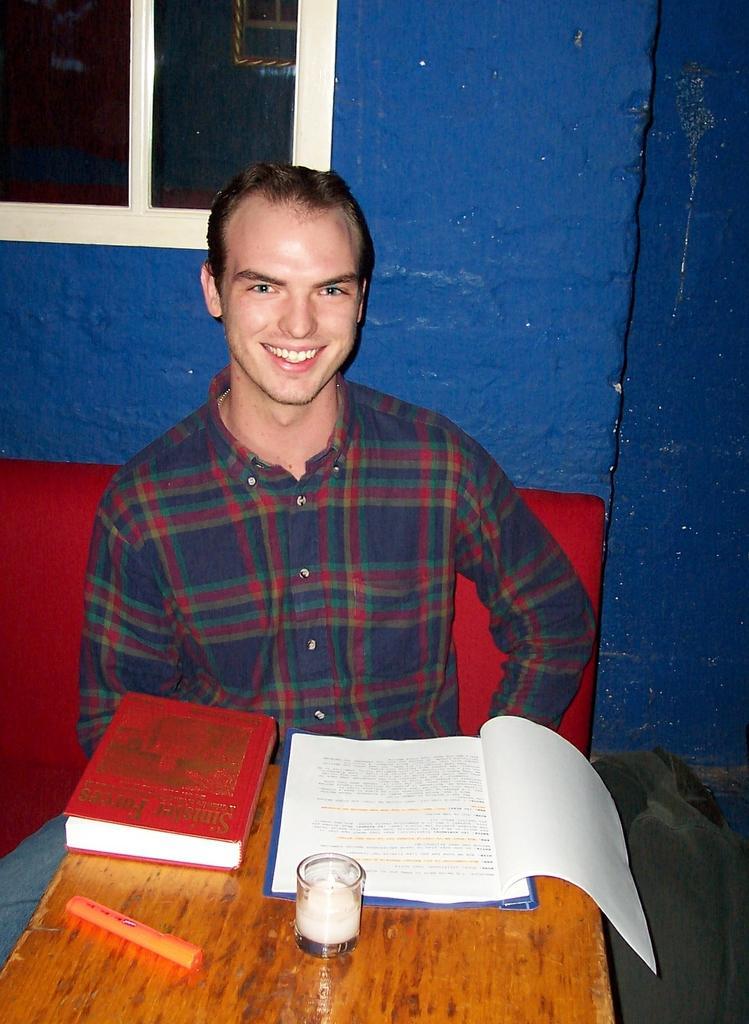Could you give a brief overview of what you see in this image? Here the guy is sitting on a bench with a table in front of him which consists of books and a glass, behind him there is window 